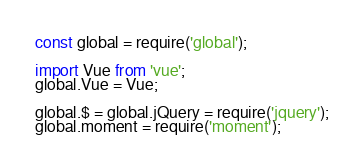Convert code to text. <code><loc_0><loc_0><loc_500><loc_500><_JavaScript_>const global = require('global');

import Vue from 'vue';
global.Vue = Vue;

global.$ = global.jQuery = require('jquery');
global.moment = require('moment');</code> 